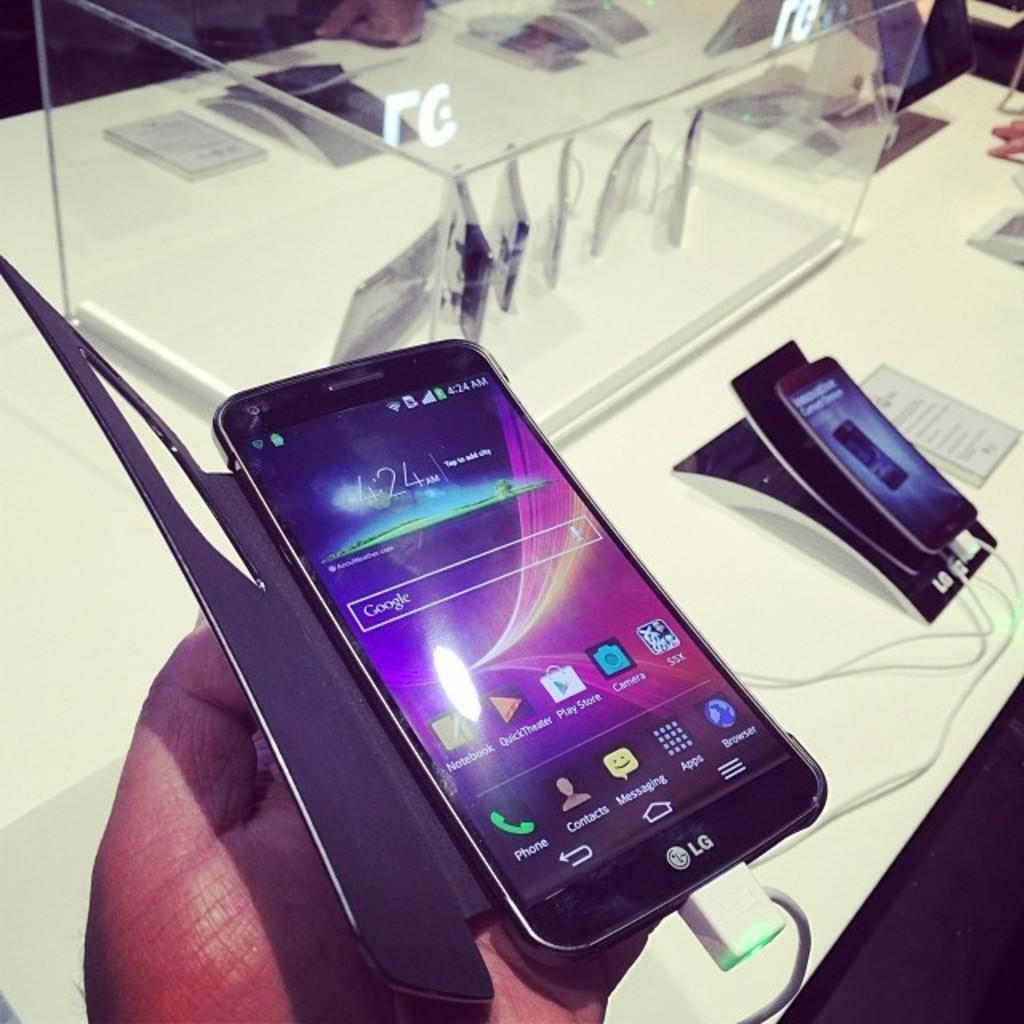<image>
Share a concise interpretation of the image provided. New curved LG smartphone with a case on it in a store at a hands on display. 